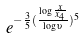Convert formula to latex. <formula><loc_0><loc_0><loc_500><loc_500>e ^ { - \frac { 3 } { 5 } ( \frac { \log \frac { x } { x _ { 4 } } } { \log \upsilon } ) ^ { 5 } }</formula> 